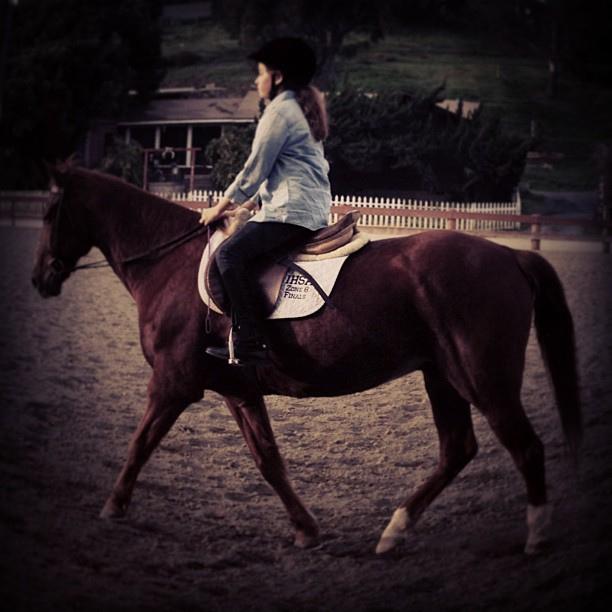Is the saddle western?
Give a very brief answer. Yes. What kind of horse is in the picture?
Answer briefly. Thoroughbred. What color is the fence?
Write a very short answer. White. 